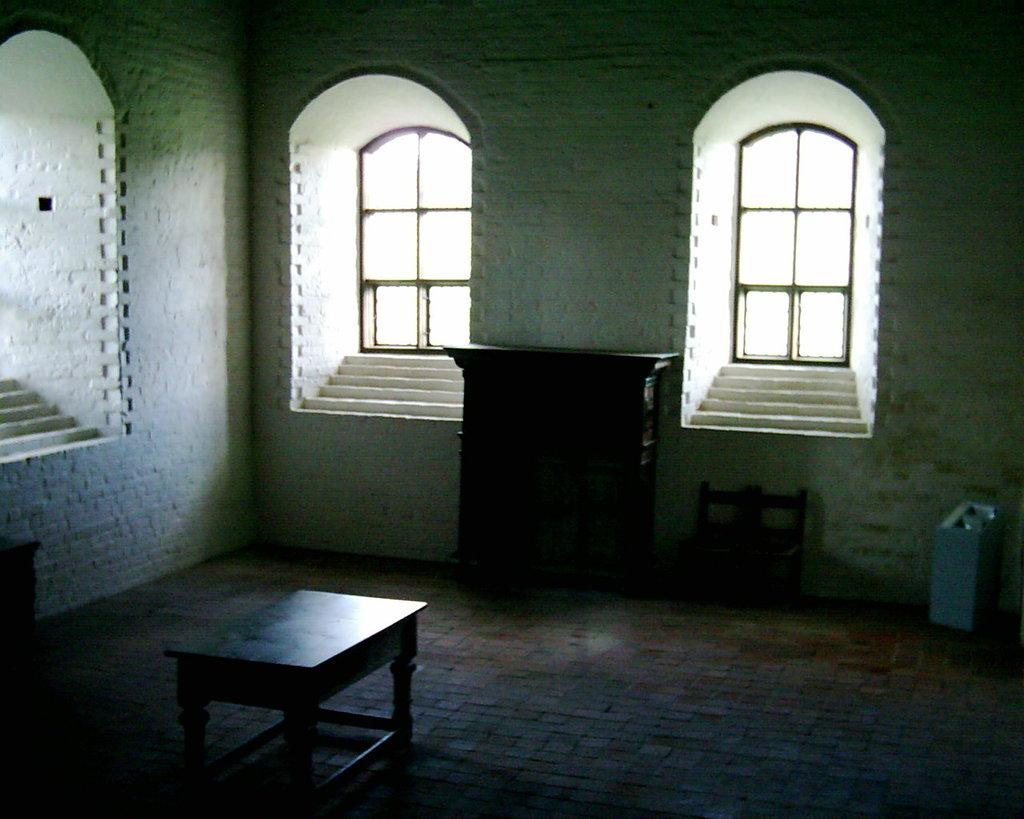What type of furniture is on the floor in the image? There is a table and a cupboard on the floor in the image. What else can be seen on the floor besides the furniture? There are other objects on the floor in the image. How is the wall in the image decorated? The wall is painted with white paint. What can be seen through the windows in the image? The presence of windows suggests that there is a view outside, but the specifics cannot be determined from the provided facts. What verse is written on the cupboard in the image? There is no verse written on the cupboard in the image. Is there a bottle visible on the table in the image? The provided facts do not mention a bottle, so it cannot be determined if one is present. 